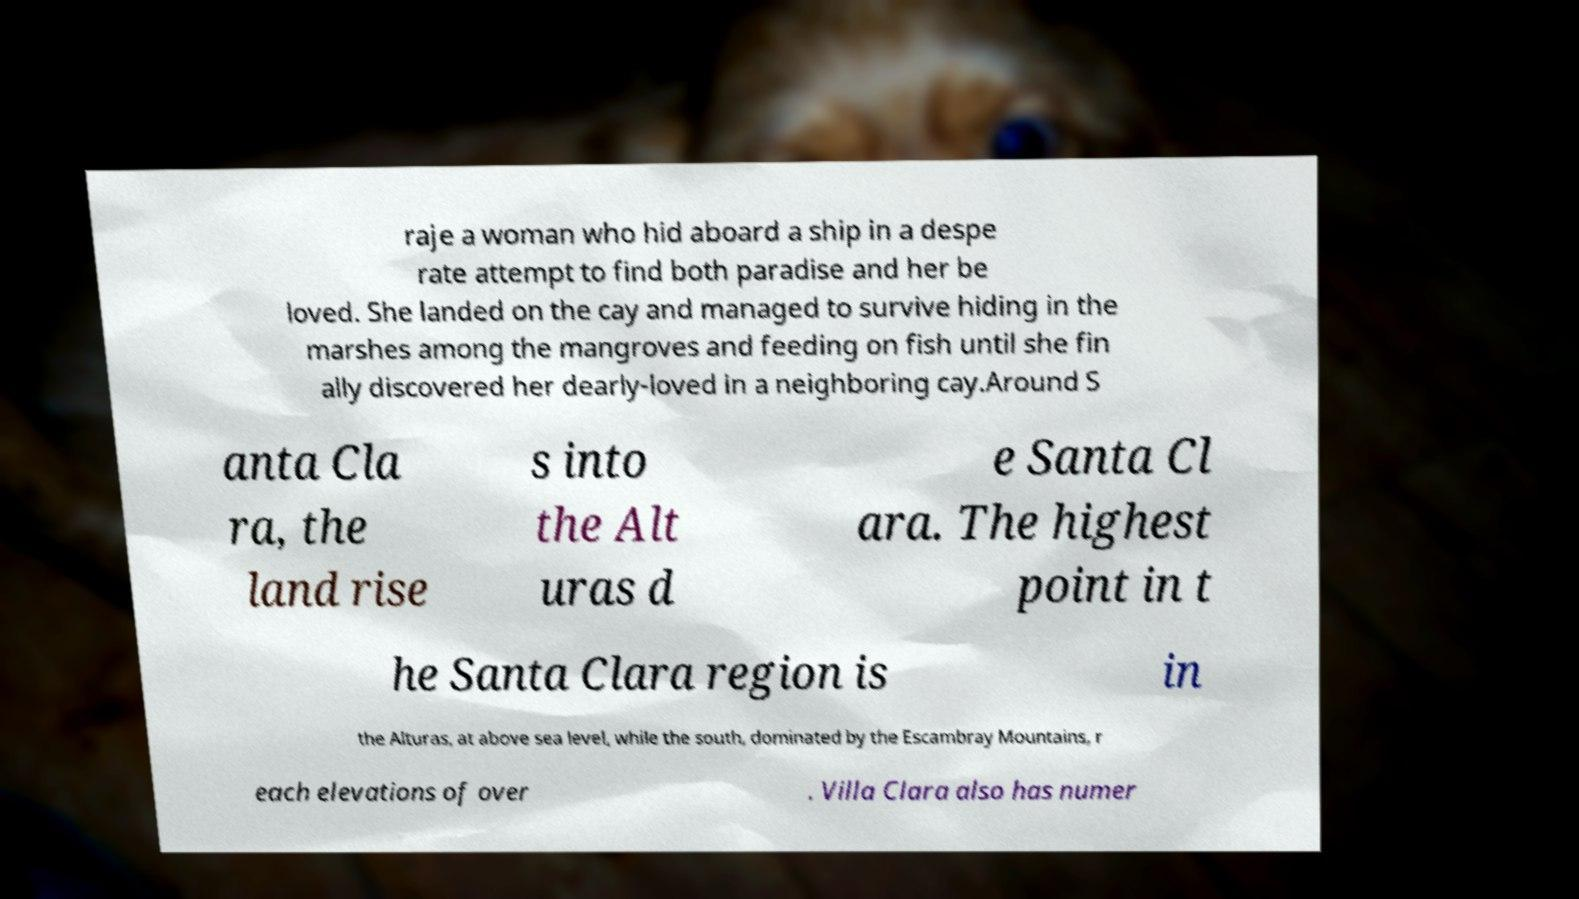Could you assist in decoding the text presented in this image and type it out clearly? raje a woman who hid aboard a ship in a despe rate attempt to find both paradise and her be loved. She landed on the cay and managed to survive hiding in the marshes among the mangroves and feeding on fish until she fin ally discovered her dearly-loved in a neighboring cay.Around S anta Cla ra, the land rise s into the Alt uras d e Santa Cl ara. The highest point in t he Santa Clara region is in the Alturas, at above sea level, while the south, dominated by the Escambray Mountains, r each elevations of over . Villa Clara also has numer 